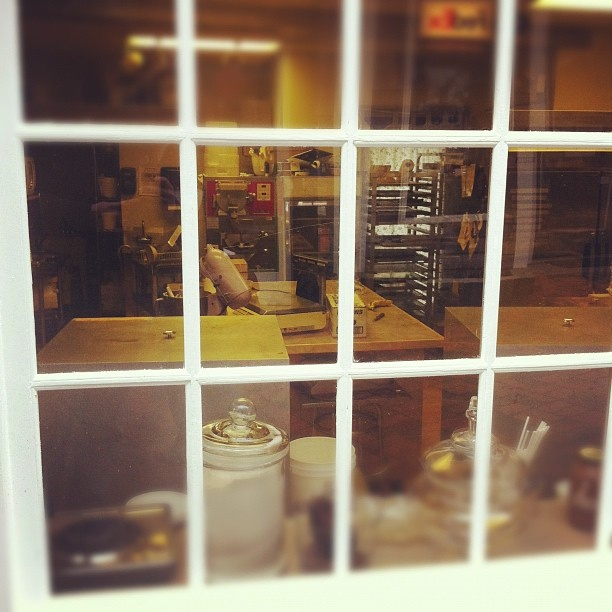Describe the objects in this image and their specific colors. I can see dining table in lightgray, brown, ivory, and maroon tones and dining table in lightgray, brown, gray, and maroon tones in this image. 